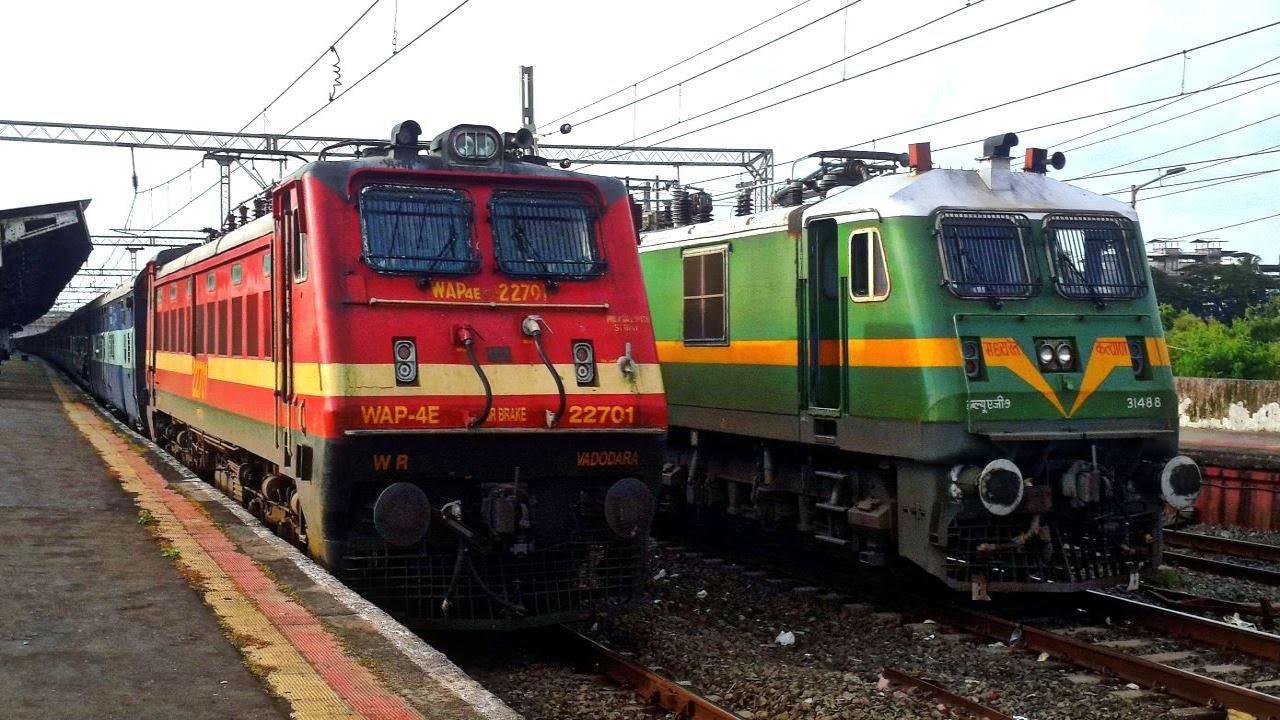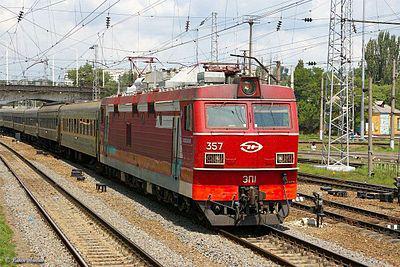The first image is the image on the left, the second image is the image on the right. Assess this claim about the two images: "There are at least four train cars in the image on the right.". Correct or not? Answer yes or no. Yes. 